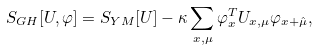Convert formula to latex. <formula><loc_0><loc_0><loc_500><loc_500>S _ { G H } [ U , \varphi ] = S _ { Y M } [ U ] - \kappa \sum _ { x , \mu } \varphi ^ { T } _ { x } U _ { x , \mu } \varphi _ { x + \hat { \mu } } ,</formula> 